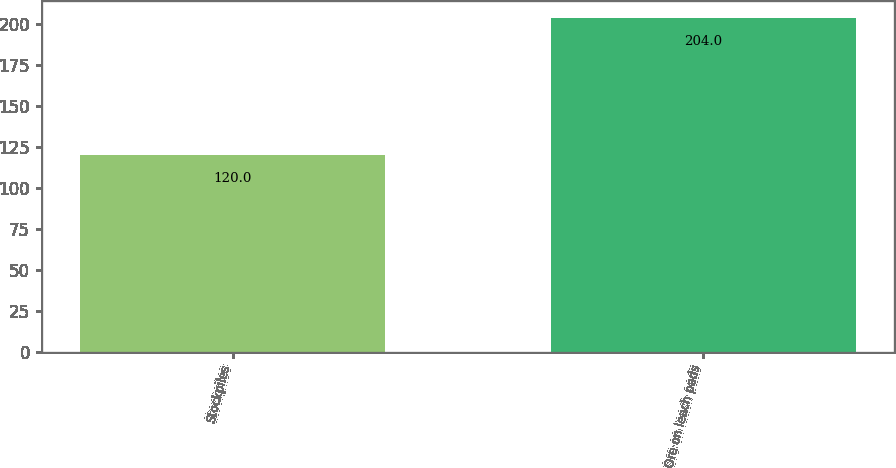<chart> <loc_0><loc_0><loc_500><loc_500><bar_chart><fcel>Stockpiles<fcel>Ore on leach pads<nl><fcel>120<fcel>204<nl></chart> 